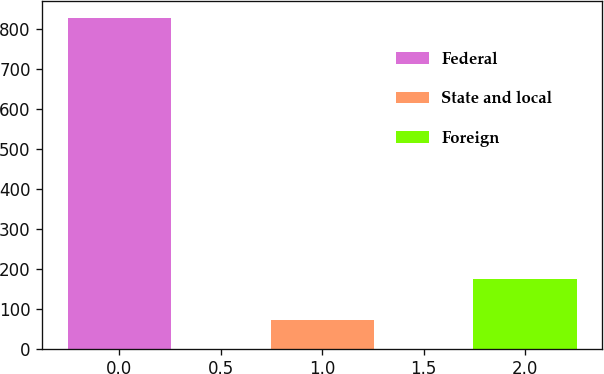<chart> <loc_0><loc_0><loc_500><loc_500><bar_chart><fcel>Federal<fcel>State and local<fcel>Foreign<nl><fcel>829<fcel>72<fcel>174<nl></chart> 